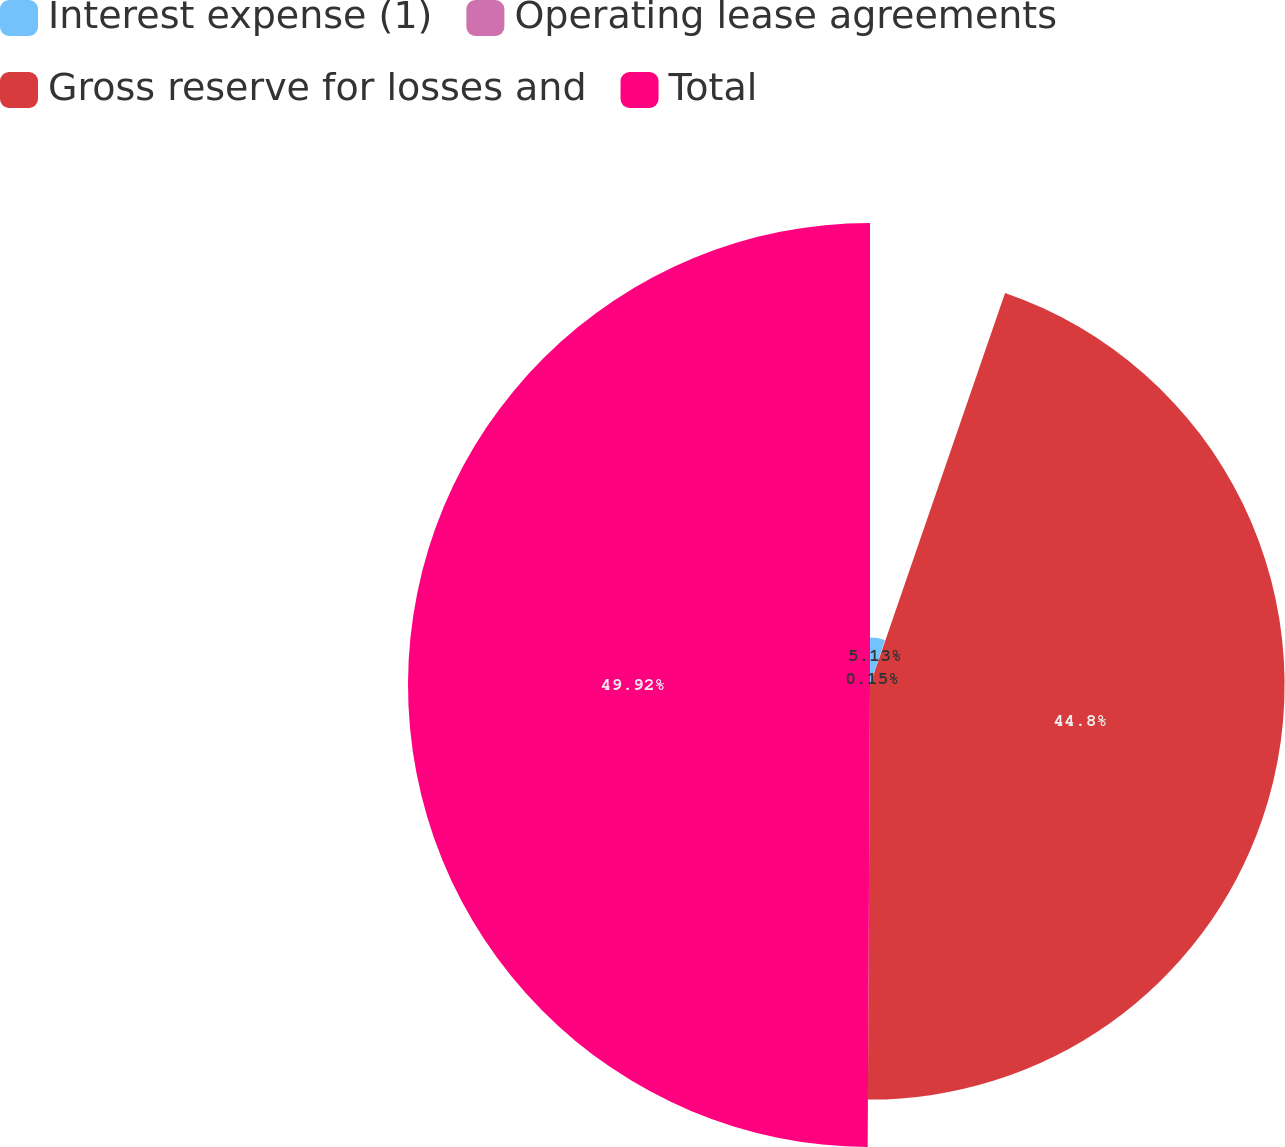<chart> <loc_0><loc_0><loc_500><loc_500><pie_chart><fcel>Interest expense (1)<fcel>Operating lease agreements<fcel>Gross reserve for losses and<fcel>Total<nl><fcel>5.13%<fcel>0.15%<fcel>44.8%<fcel>49.92%<nl></chart> 